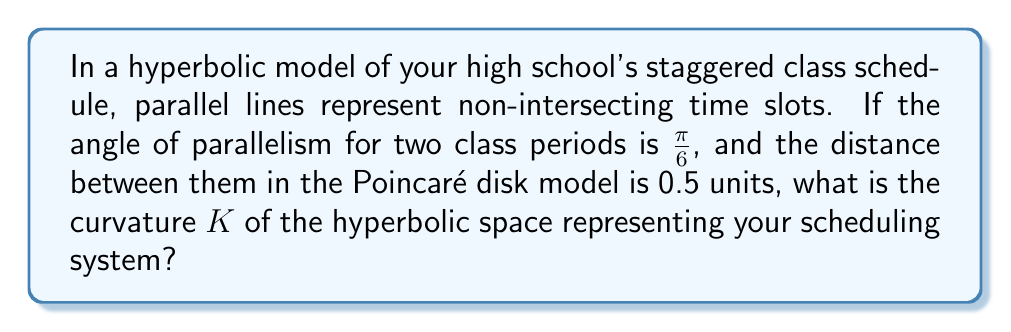Can you answer this question? Let's approach this step-by-step:

1) In hyperbolic geometry, the angle of parallelism $\Pi(d)$ is related to the distance $d$ between parallel lines by the formula:

   $$\Pi(d) = 2 \arctan(e^{-d\sqrt{-K}})$$

   where $K$ is the curvature of the hyperbolic space.

2) We're given that $\Pi(d) = \frac{\pi}{6}$ and $d = 0.5$. Let's substitute these into the formula:

   $$\frac{\pi}{6} = 2 \arctan(e^{-0.5\sqrt{-K}})$$

3) Simplify the left side:

   $$\frac{\pi}{12} = \arctan(e^{-0.5\sqrt{-K}})$$

4) Apply tan to both sides:

   $$\tan(\frac{\pi}{12}) = e^{-0.5\sqrt{-K}}$$

5) Take the natural log of both sides:

   $$\ln(\tan(\frac{\pi}{12})) = -0.5\sqrt{-K}$$

6) Multiply both sides by -2:

   $$-2\ln(\tan(\frac{\pi}{12})) = \sqrt{-K}$$

7) Square both sides:

   $$4(\ln(\tan(\frac{\pi}{12})))^2 = -K$$

8) Solve for $K$:

   $$K = -4(\ln(\tan(\frac{\pi}{12})))^2$$

9) Calculate the value (you can use a calculator for this):

   $$K \approx -3.525$$

Thus, the curvature of the hyperbolic space representing your scheduling system is approximately -3.525.
Answer: $K \approx -3.525$ 